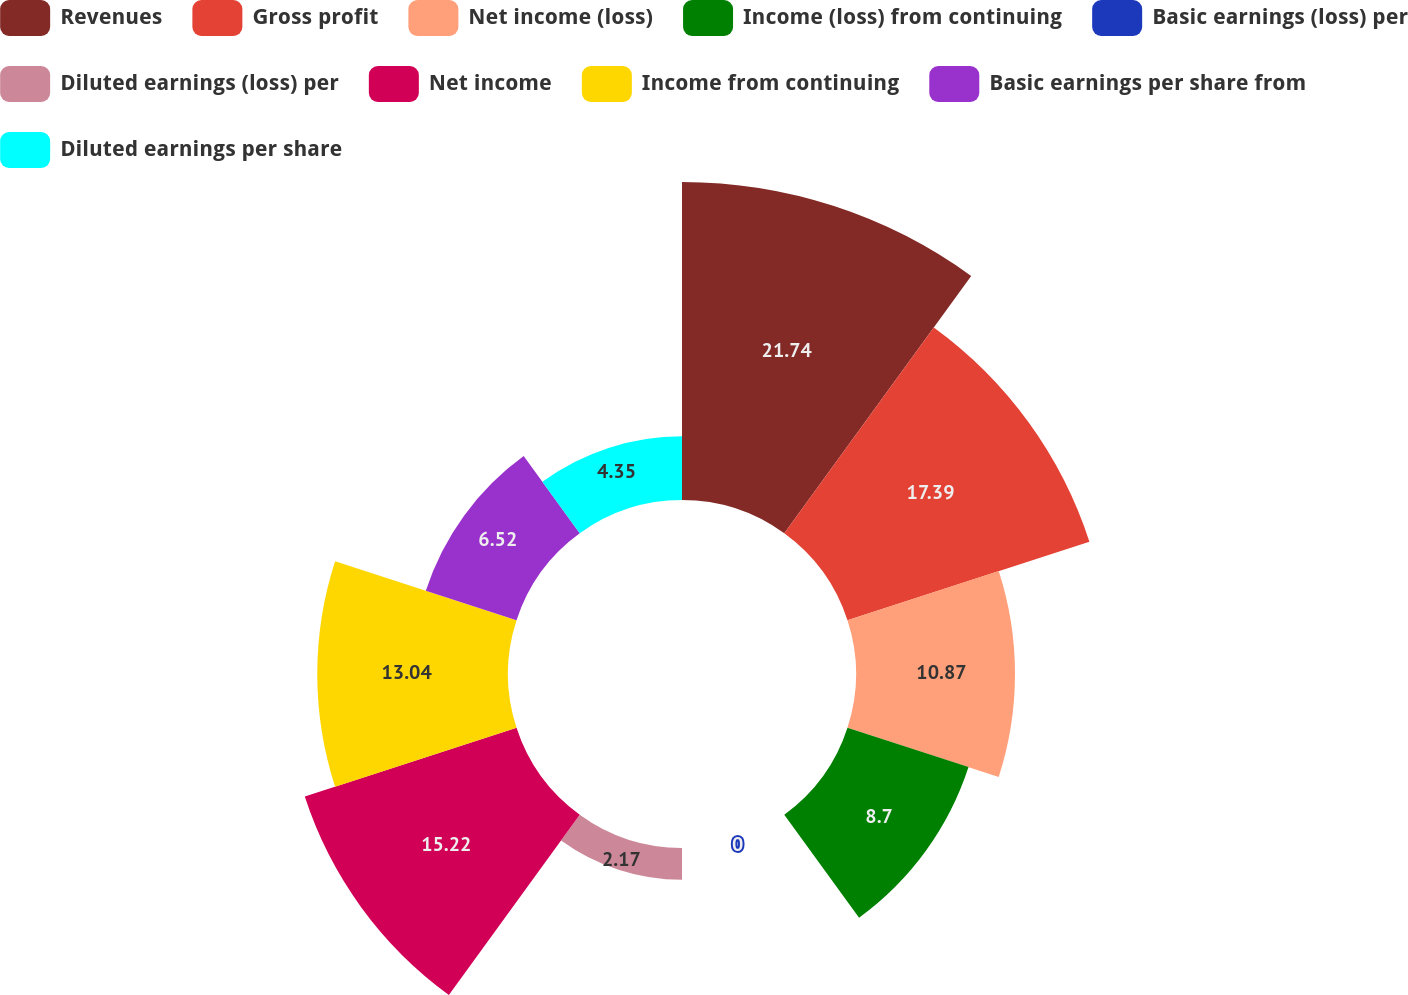Convert chart to OTSL. <chart><loc_0><loc_0><loc_500><loc_500><pie_chart><fcel>Revenues<fcel>Gross profit<fcel>Net income (loss)<fcel>Income (loss) from continuing<fcel>Basic earnings (loss) per<fcel>Diluted earnings (loss) per<fcel>Net income<fcel>Income from continuing<fcel>Basic earnings per share from<fcel>Diluted earnings per share<nl><fcel>21.74%<fcel>17.39%<fcel>10.87%<fcel>8.7%<fcel>0.0%<fcel>2.17%<fcel>15.22%<fcel>13.04%<fcel>6.52%<fcel>4.35%<nl></chart> 